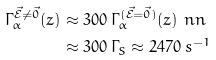Convert formula to latex. <formula><loc_0><loc_0><loc_500><loc_500>\Gamma ^ { \vec { \mathcal { E } } \not = \vec { 0 } } _ { \alpha } ( z ) & \approx 3 0 0 \, \Gamma ^ { ( \vec { \mathcal { E } } = \vec { 0 } ) } _ { \alpha } ( z ) \ n n \\ & \approx 3 0 0 \, \Gamma _ { S } \approx 2 4 7 0 \, s ^ { - 1 }</formula> 